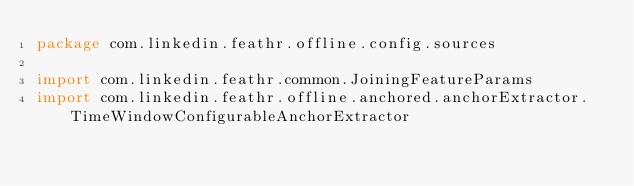Convert code to text. <code><loc_0><loc_0><loc_500><loc_500><_Scala_>package com.linkedin.feathr.offline.config.sources

import com.linkedin.feathr.common.JoiningFeatureParams
import com.linkedin.feathr.offline.anchored.anchorExtractor.TimeWindowConfigurableAnchorExtractor</code> 